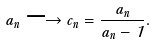<formula> <loc_0><loc_0><loc_500><loc_500>a _ { n } \longrightarrow c _ { n } = \frac { a _ { n } } { a _ { n } - 1 } .</formula> 